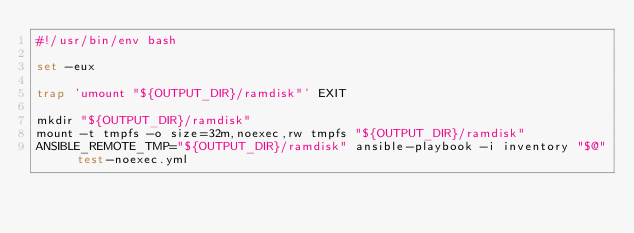<code> <loc_0><loc_0><loc_500><loc_500><_Bash_>#!/usr/bin/env bash

set -eux

trap 'umount "${OUTPUT_DIR}/ramdisk"' EXIT

mkdir "${OUTPUT_DIR}/ramdisk"
mount -t tmpfs -o size=32m,noexec,rw tmpfs "${OUTPUT_DIR}/ramdisk"
ANSIBLE_REMOTE_TMP="${OUTPUT_DIR}/ramdisk" ansible-playbook -i inventory "$@" test-noexec.yml
</code> 